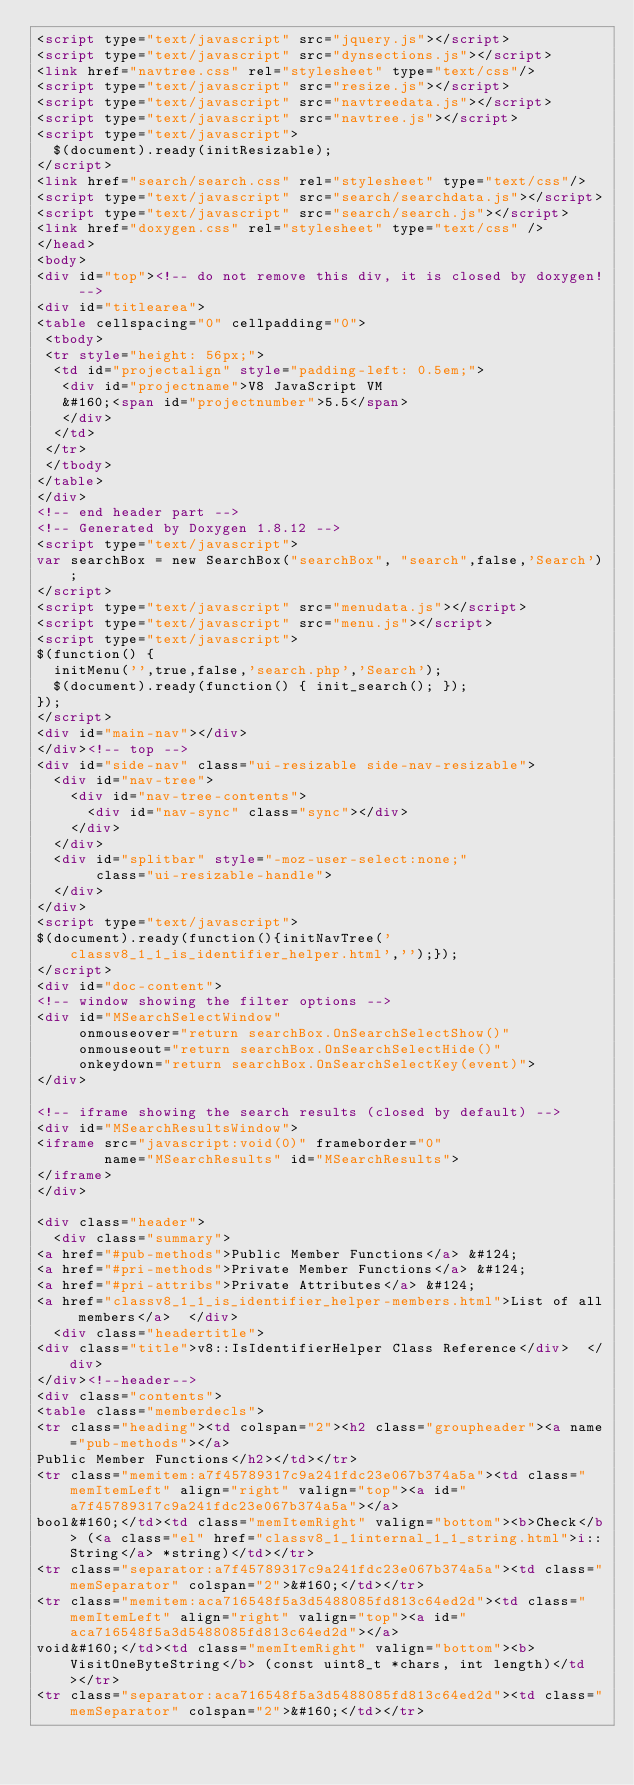<code> <loc_0><loc_0><loc_500><loc_500><_HTML_><script type="text/javascript" src="jquery.js"></script>
<script type="text/javascript" src="dynsections.js"></script>
<link href="navtree.css" rel="stylesheet" type="text/css"/>
<script type="text/javascript" src="resize.js"></script>
<script type="text/javascript" src="navtreedata.js"></script>
<script type="text/javascript" src="navtree.js"></script>
<script type="text/javascript">
  $(document).ready(initResizable);
</script>
<link href="search/search.css" rel="stylesheet" type="text/css"/>
<script type="text/javascript" src="search/searchdata.js"></script>
<script type="text/javascript" src="search/search.js"></script>
<link href="doxygen.css" rel="stylesheet" type="text/css" />
</head>
<body>
<div id="top"><!-- do not remove this div, it is closed by doxygen! -->
<div id="titlearea">
<table cellspacing="0" cellpadding="0">
 <tbody>
 <tr style="height: 56px;">
  <td id="projectalign" style="padding-left: 0.5em;">
   <div id="projectname">V8 JavaScript VM
   &#160;<span id="projectnumber">5.5</span>
   </div>
  </td>
 </tr>
 </tbody>
</table>
</div>
<!-- end header part -->
<!-- Generated by Doxygen 1.8.12 -->
<script type="text/javascript">
var searchBox = new SearchBox("searchBox", "search",false,'Search');
</script>
<script type="text/javascript" src="menudata.js"></script>
<script type="text/javascript" src="menu.js"></script>
<script type="text/javascript">
$(function() {
  initMenu('',true,false,'search.php','Search');
  $(document).ready(function() { init_search(); });
});
</script>
<div id="main-nav"></div>
</div><!-- top -->
<div id="side-nav" class="ui-resizable side-nav-resizable">
  <div id="nav-tree">
    <div id="nav-tree-contents">
      <div id="nav-sync" class="sync"></div>
    </div>
  </div>
  <div id="splitbar" style="-moz-user-select:none;" 
       class="ui-resizable-handle">
  </div>
</div>
<script type="text/javascript">
$(document).ready(function(){initNavTree('classv8_1_1_is_identifier_helper.html','');});
</script>
<div id="doc-content">
<!-- window showing the filter options -->
<div id="MSearchSelectWindow"
     onmouseover="return searchBox.OnSearchSelectShow()"
     onmouseout="return searchBox.OnSearchSelectHide()"
     onkeydown="return searchBox.OnSearchSelectKey(event)">
</div>

<!-- iframe showing the search results (closed by default) -->
<div id="MSearchResultsWindow">
<iframe src="javascript:void(0)" frameborder="0" 
        name="MSearchResults" id="MSearchResults">
</iframe>
</div>

<div class="header">
  <div class="summary">
<a href="#pub-methods">Public Member Functions</a> &#124;
<a href="#pri-methods">Private Member Functions</a> &#124;
<a href="#pri-attribs">Private Attributes</a> &#124;
<a href="classv8_1_1_is_identifier_helper-members.html">List of all members</a>  </div>
  <div class="headertitle">
<div class="title">v8::IsIdentifierHelper Class Reference</div>  </div>
</div><!--header-->
<div class="contents">
<table class="memberdecls">
<tr class="heading"><td colspan="2"><h2 class="groupheader"><a name="pub-methods"></a>
Public Member Functions</h2></td></tr>
<tr class="memitem:a7f45789317c9a241fdc23e067b374a5a"><td class="memItemLeft" align="right" valign="top"><a id="a7f45789317c9a241fdc23e067b374a5a"></a>
bool&#160;</td><td class="memItemRight" valign="bottom"><b>Check</b> (<a class="el" href="classv8_1_1internal_1_1_string.html">i::String</a> *string)</td></tr>
<tr class="separator:a7f45789317c9a241fdc23e067b374a5a"><td class="memSeparator" colspan="2">&#160;</td></tr>
<tr class="memitem:aca716548f5a3d5488085fd813c64ed2d"><td class="memItemLeft" align="right" valign="top"><a id="aca716548f5a3d5488085fd813c64ed2d"></a>
void&#160;</td><td class="memItemRight" valign="bottom"><b>VisitOneByteString</b> (const uint8_t *chars, int length)</td></tr>
<tr class="separator:aca716548f5a3d5488085fd813c64ed2d"><td class="memSeparator" colspan="2">&#160;</td></tr></code> 